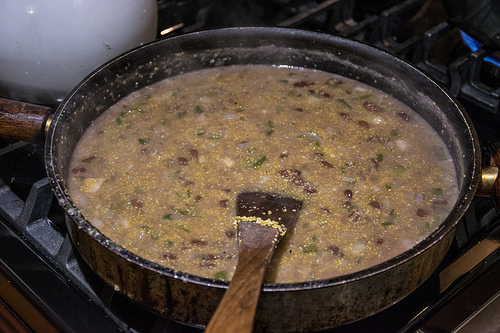<image>
Is there a soup next to the gas? No. The soup is not positioned next to the gas. They are located in different areas of the scene. 